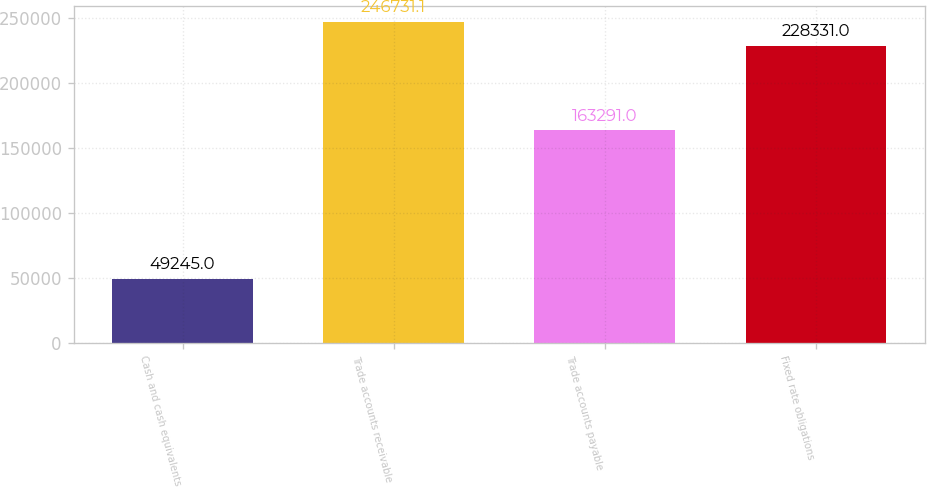Convert chart. <chart><loc_0><loc_0><loc_500><loc_500><bar_chart><fcel>Cash and cash equivalents<fcel>Trade accounts receivable<fcel>Trade accounts payable<fcel>Fixed rate obligations<nl><fcel>49245<fcel>246731<fcel>163291<fcel>228331<nl></chart> 